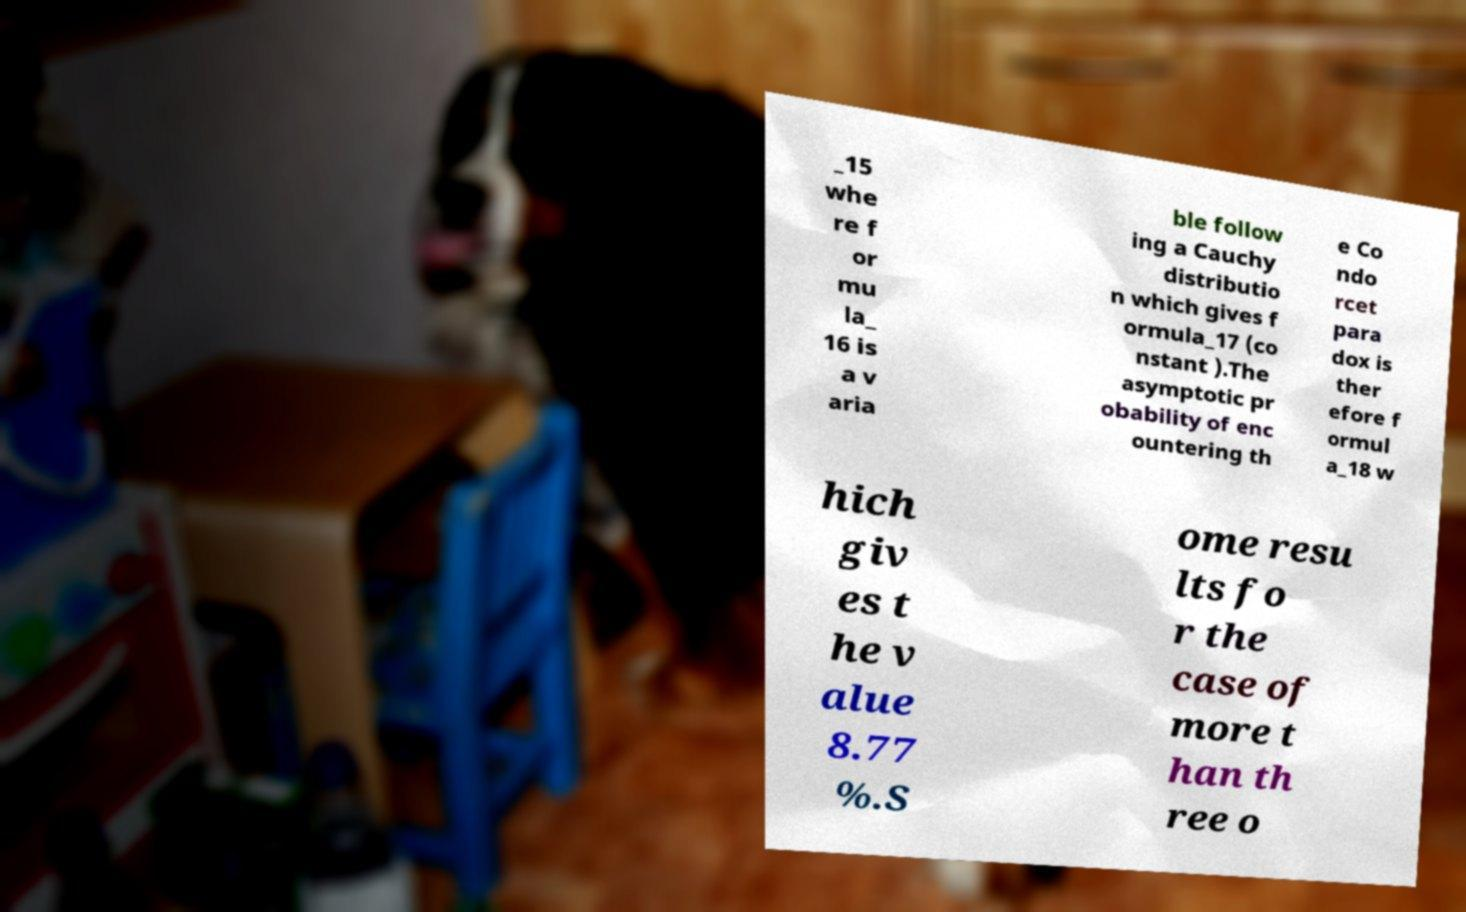I need the written content from this picture converted into text. Can you do that? _15 whe re f or mu la_ 16 is a v aria ble follow ing a Cauchy distributio n which gives f ormula_17 (co nstant ).The asymptotic pr obability of enc ountering th e Co ndo rcet para dox is ther efore f ormul a_18 w hich giv es t he v alue 8.77 %.S ome resu lts fo r the case of more t han th ree o 